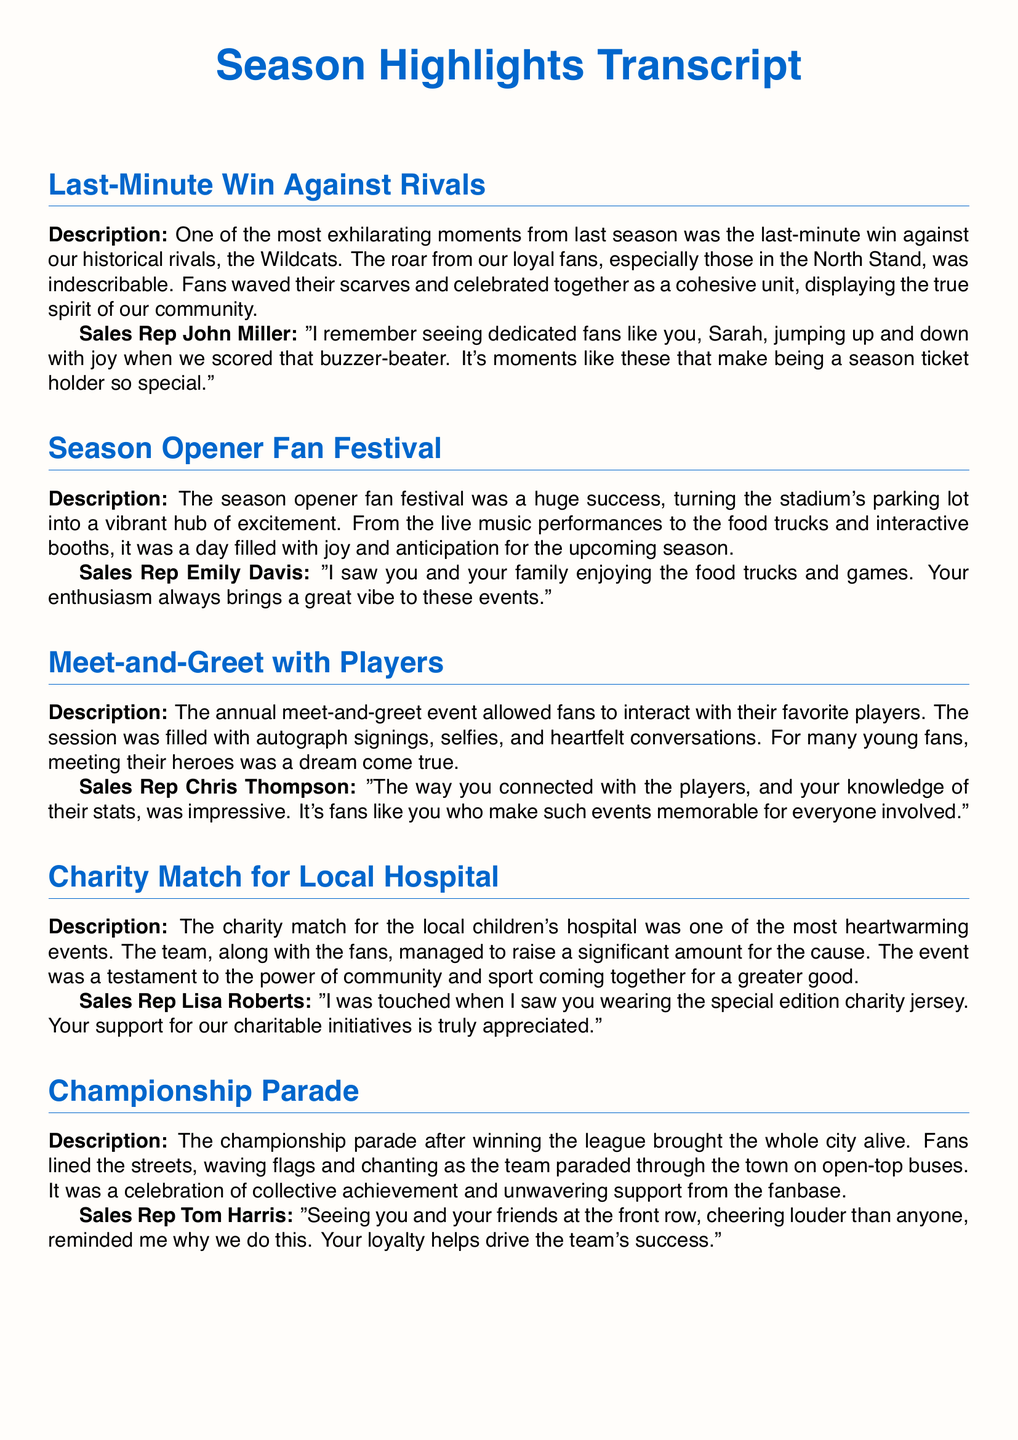what was the last-minute win against? The last-minute win was against the historical rivals, the Wildcats.
Answer: Wildcats who commented on the last-minute win? The sales representative who commented on the last-minute win was John Miller.
Answer: John Miller what event took place during the season opener? During the season opener, a fan festival took place.
Answer: fan festival who did fans meet at the annual event? Fans met their favorite players at the annual event.
Answer: favorite players what was the purpose of the charity match? The purpose of the charity match was to raise funds for the local children's hospital.
Answer: raise funds which special item did one fan wear at the charity match? The fan wore a special edition charity jersey at the charity match.
Answer: special edition charity jersey what was the nature of the championship parade? The championship parade was a celebration of collective achievement.
Answer: celebration who noted the fan’s knowledge of player stats? Chris Thompson noted the fan's knowledge of player stats.
Answer: Chris Thompson how did fans respond during the championship parade? Fans lined the streets, waving flags and chanting during the championship parade.
Answer: waving flags and chanting 